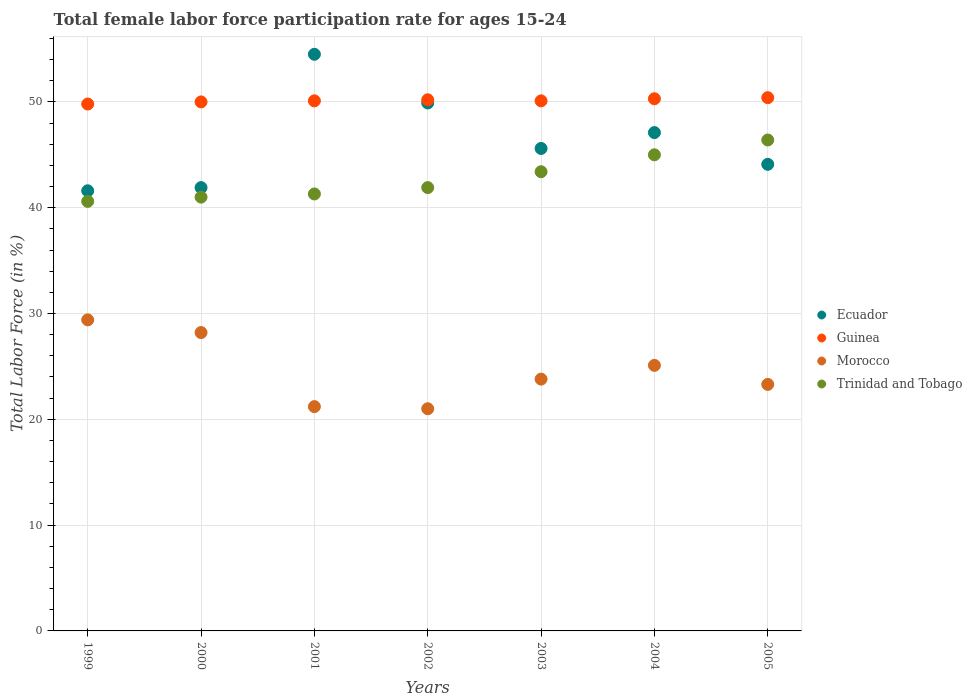Is the number of dotlines equal to the number of legend labels?
Offer a terse response. Yes. What is the female labor force participation rate in Ecuador in 2005?
Your response must be concise. 44.1. Across all years, what is the maximum female labor force participation rate in Guinea?
Offer a very short reply. 50.4. Across all years, what is the minimum female labor force participation rate in Ecuador?
Ensure brevity in your answer.  41.6. In which year was the female labor force participation rate in Guinea minimum?
Keep it short and to the point. 1999. What is the total female labor force participation rate in Morocco in the graph?
Offer a very short reply. 172. What is the difference between the female labor force participation rate in Guinea in 1999 and that in 2001?
Ensure brevity in your answer.  -0.3. What is the difference between the female labor force participation rate in Ecuador in 1999 and the female labor force participation rate in Guinea in 2005?
Provide a short and direct response. -8.8. What is the average female labor force participation rate in Guinea per year?
Ensure brevity in your answer.  50.13. In the year 2002, what is the difference between the female labor force participation rate in Morocco and female labor force participation rate in Ecuador?
Make the answer very short. -28.9. What is the ratio of the female labor force participation rate in Guinea in 2000 to that in 2003?
Offer a terse response. 1. Is the female labor force participation rate in Trinidad and Tobago in 2001 less than that in 2005?
Offer a very short reply. Yes. What is the difference between the highest and the second highest female labor force participation rate in Guinea?
Provide a succinct answer. 0.1. What is the difference between the highest and the lowest female labor force participation rate in Trinidad and Tobago?
Ensure brevity in your answer.  5.8. Does the female labor force participation rate in Trinidad and Tobago monotonically increase over the years?
Your answer should be very brief. Yes. Is the female labor force participation rate in Guinea strictly greater than the female labor force participation rate in Trinidad and Tobago over the years?
Your answer should be compact. Yes. How many dotlines are there?
Offer a very short reply. 4. Does the graph contain any zero values?
Give a very brief answer. No. How many legend labels are there?
Ensure brevity in your answer.  4. How are the legend labels stacked?
Provide a succinct answer. Vertical. What is the title of the graph?
Your answer should be compact. Total female labor force participation rate for ages 15-24. What is the label or title of the X-axis?
Provide a succinct answer. Years. What is the Total Labor Force (in %) of Ecuador in 1999?
Ensure brevity in your answer.  41.6. What is the Total Labor Force (in %) in Guinea in 1999?
Your answer should be very brief. 49.8. What is the Total Labor Force (in %) in Morocco in 1999?
Keep it short and to the point. 29.4. What is the Total Labor Force (in %) in Trinidad and Tobago in 1999?
Provide a succinct answer. 40.6. What is the Total Labor Force (in %) in Ecuador in 2000?
Provide a short and direct response. 41.9. What is the Total Labor Force (in %) in Morocco in 2000?
Your answer should be compact. 28.2. What is the Total Labor Force (in %) of Ecuador in 2001?
Ensure brevity in your answer.  54.5. What is the Total Labor Force (in %) in Guinea in 2001?
Give a very brief answer. 50.1. What is the Total Labor Force (in %) in Morocco in 2001?
Provide a succinct answer. 21.2. What is the Total Labor Force (in %) in Trinidad and Tobago in 2001?
Make the answer very short. 41.3. What is the Total Labor Force (in %) in Ecuador in 2002?
Make the answer very short. 49.9. What is the Total Labor Force (in %) of Guinea in 2002?
Your answer should be very brief. 50.2. What is the Total Labor Force (in %) of Trinidad and Tobago in 2002?
Your answer should be very brief. 41.9. What is the Total Labor Force (in %) of Ecuador in 2003?
Offer a terse response. 45.6. What is the Total Labor Force (in %) in Guinea in 2003?
Your response must be concise. 50.1. What is the Total Labor Force (in %) in Morocco in 2003?
Keep it short and to the point. 23.8. What is the Total Labor Force (in %) of Trinidad and Tobago in 2003?
Keep it short and to the point. 43.4. What is the Total Labor Force (in %) of Ecuador in 2004?
Ensure brevity in your answer.  47.1. What is the Total Labor Force (in %) in Guinea in 2004?
Provide a short and direct response. 50.3. What is the Total Labor Force (in %) in Morocco in 2004?
Offer a terse response. 25.1. What is the Total Labor Force (in %) of Trinidad and Tobago in 2004?
Your answer should be very brief. 45. What is the Total Labor Force (in %) in Ecuador in 2005?
Your response must be concise. 44.1. What is the Total Labor Force (in %) in Guinea in 2005?
Provide a short and direct response. 50.4. What is the Total Labor Force (in %) in Morocco in 2005?
Your answer should be compact. 23.3. What is the Total Labor Force (in %) in Trinidad and Tobago in 2005?
Give a very brief answer. 46.4. Across all years, what is the maximum Total Labor Force (in %) in Ecuador?
Provide a short and direct response. 54.5. Across all years, what is the maximum Total Labor Force (in %) in Guinea?
Provide a short and direct response. 50.4. Across all years, what is the maximum Total Labor Force (in %) of Morocco?
Ensure brevity in your answer.  29.4. Across all years, what is the maximum Total Labor Force (in %) in Trinidad and Tobago?
Make the answer very short. 46.4. Across all years, what is the minimum Total Labor Force (in %) in Ecuador?
Give a very brief answer. 41.6. Across all years, what is the minimum Total Labor Force (in %) of Guinea?
Provide a short and direct response. 49.8. Across all years, what is the minimum Total Labor Force (in %) of Morocco?
Offer a terse response. 21. Across all years, what is the minimum Total Labor Force (in %) of Trinidad and Tobago?
Make the answer very short. 40.6. What is the total Total Labor Force (in %) in Ecuador in the graph?
Ensure brevity in your answer.  324.7. What is the total Total Labor Force (in %) of Guinea in the graph?
Offer a terse response. 350.9. What is the total Total Labor Force (in %) in Morocco in the graph?
Provide a succinct answer. 172. What is the total Total Labor Force (in %) in Trinidad and Tobago in the graph?
Give a very brief answer. 299.6. What is the difference between the Total Labor Force (in %) of Ecuador in 1999 and that in 2000?
Give a very brief answer. -0.3. What is the difference between the Total Labor Force (in %) in Guinea in 1999 and that in 2000?
Offer a very short reply. -0.2. What is the difference between the Total Labor Force (in %) of Morocco in 1999 and that in 2000?
Give a very brief answer. 1.2. What is the difference between the Total Labor Force (in %) of Trinidad and Tobago in 1999 and that in 2000?
Make the answer very short. -0.4. What is the difference between the Total Labor Force (in %) in Guinea in 1999 and that in 2001?
Make the answer very short. -0.3. What is the difference between the Total Labor Force (in %) of Morocco in 1999 and that in 2001?
Offer a terse response. 8.2. What is the difference between the Total Labor Force (in %) of Trinidad and Tobago in 1999 and that in 2001?
Keep it short and to the point. -0.7. What is the difference between the Total Labor Force (in %) of Ecuador in 1999 and that in 2002?
Ensure brevity in your answer.  -8.3. What is the difference between the Total Labor Force (in %) of Guinea in 1999 and that in 2002?
Ensure brevity in your answer.  -0.4. What is the difference between the Total Labor Force (in %) of Morocco in 1999 and that in 2002?
Your answer should be compact. 8.4. What is the difference between the Total Labor Force (in %) in Ecuador in 1999 and that in 2003?
Offer a terse response. -4. What is the difference between the Total Labor Force (in %) in Guinea in 1999 and that in 2003?
Your answer should be compact. -0.3. What is the difference between the Total Labor Force (in %) of Morocco in 1999 and that in 2003?
Offer a terse response. 5.6. What is the difference between the Total Labor Force (in %) of Ecuador in 1999 and that in 2004?
Your answer should be compact. -5.5. What is the difference between the Total Labor Force (in %) in Morocco in 1999 and that in 2004?
Keep it short and to the point. 4.3. What is the difference between the Total Labor Force (in %) in Trinidad and Tobago in 1999 and that in 2004?
Offer a very short reply. -4.4. What is the difference between the Total Labor Force (in %) of Trinidad and Tobago in 1999 and that in 2005?
Make the answer very short. -5.8. What is the difference between the Total Labor Force (in %) in Guinea in 2000 and that in 2001?
Make the answer very short. -0.1. What is the difference between the Total Labor Force (in %) in Morocco in 2000 and that in 2001?
Keep it short and to the point. 7. What is the difference between the Total Labor Force (in %) in Trinidad and Tobago in 2000 and that in 2001?
Make the answer very short. -0.3. What is the difference between the Total Labor Force (in %) of Trinidad and Tobago in 2000 and that in 2002?
Provide a short and direct response. -0.9. What is the difference between the Total Labor Force (in %) in Ecuador in 2000 and that in 2003?
Offer a very short reply. -3.7. What is the difference between the Total Labor Force (in %) in Guinea in 2000 and that in 2003?
Provide a short and direct response. -0.1. What is the difference between the Total Labor Force (in %) in Ecuador in 2000 and that in 2004?
Offer a terse response. -5.2. What is the difference between the Total Labor Force (in %) in Guinea in 2000 and that in 2004?
Ensure brevity in your answer.  -0.3. What is the difference between the Total Labor Force (in %) of Morocco in 2000 and that in 2004?
Offer a terse response. 3.1. What is the difference between the Total Labor Force (in %) of Guinea in 2000 and that in 2005?
Your response must be concise. -0.4. What is the difference between the Total Labor Force (in %) of Morocco in 2000 and that in 2005?
Your answer should be very brief. 4.9. What is the difference between the Total Labor Force (in %) in Trinidad and Tobago in 2000 and that in 2005?
Your answer should be compact. -5.4. What is the difference between the Total Labor Force (in %) in Ecuador in 2001 and that in 2002?
Your response must be concise. 4.6. What is the difference between the Total Labor Force (in %) of Guinea in 2001 and that in 2002?
Your answer should be very brief. -0.1. What is the difference between the Total Labor Force (in %) of Trinidad and Tobago in 2001 and that in 2002?
Your answer should be very brief. -0.6. What is the difference between the Total Labor Force (in %) in Ecuador in 2001 and that in 2003?
Offer a very short reply. 8.9. What is the difference between the Total Labor Force (in %) in Guinea in 2001 and that in 2003?
Offer a very short reply. 0. What is the difference between the Total Labor Force (in %) in Morocco in 2001 and that in 2003?
Offer a terse response. -2.6. What is the difference between the Total Labor Force (in %) in Trinidad and Tobago in 2001 and that in 2003?
Make the answer very short. -2.1. What is the difference between the Total Labor Force (in %) in Guinea in 2001 and that in 2004?
Offer a terse response. -0.2. What is the difference between the Total Labor Force (in %) in Guinea in 2001 and that in 2005?
Offer a very short reply. -0.3. What is the difference between the Total Labor Force (in %) of Trinidad and Tobago in 2002 and that in 2003?
Provide a short and direct response. -1.5. What is the difference between the Total Labor Force (in %) of Morocco in 2002 and that in 2004?
Ensure brevity in your answer.  -4.1. What is the difference between the Total Labor Force (in %) in Guinea in 2002 and that in 2005?
Offer a terse response. -0.2. What is the difference between the Total Labor Force (in %) in Morocco in 2002 and that in 2005?
Your answer should be compact. -2.3. What is the difference between the Total Labor Force (in %) of Trinidad and Tobago in 2002 and that in 2005?
Your answer should be compact. -4.5. What is the difference between the Total Labor Force (in %) in Ecuador in 2003 and that in 2004?
Provide a short and direct response. -1.5. What is the difference between the Total Labor Force (in %) in Ecuador in 2003 and that in 2005?
Ensure brevity in your answer.  1.5. What is the difference between the Total Labor Force (in %) in Trinidad and Tobago in 2003 and that in 2005?
Provide a succinct answer. -3. What is the difference between the Total Labor Force (in %) of Ecuador in 2004 and that in 2005?
Provide a succinct answer. 3. What is the difference between the Total Labor Force (in %) in Morocco in 2004 and that in 2005?
Give a very brief answer. 1.8. What is the difference between the Total Labor Force (in %) of Trinidad and Tobago in 2004 and that in 2005?
Provide a succinct answer. -1.4. What is the difference between the Total Labor Force (in %) in Ecuador in 1999 and the Total Labor Force (in %) in Morocco in 2000?
Offer a very short reply. 13.4. What is the difference between the Total Labor Force (in %) of Guinea in 1999 and the Total Labor Force (in %) of Morocco in 2000?
Your answer should be compact. 21.6. What is the difference between the Total Labor Force (in %) in Guinea in 1999 and the Total Labor Force (in %) in Trinidad and Tobago in 2000?
Your answer should be compact. 8.8. What is the difference between the Total Labor Force (in %) of Morocco in 1999 and the Total Labor Force (in %) of Trinidad and Tobago in 2000?
Keep it short and to the point. -11.6. What is the difference between the Total Labor Force (in %) in Ecuador in 1999 and the Total Labor Force (in %) in Guinea in 2001?
Ensure brevity in your answer.  -8.5. What is the difference between the Total Labor Force (in %) in Ecuador in 1999 and the Total Labor Force (in %) in Morocco in 2001?
Provide a succinct answer. 20.4. What is the difference between the Total Labor Force (in %) of Ecuador in 1999 and the Total Labor Force (in %) of Trinidad and Tobago in 2001?
Offer a terse response. 0.3. What is the difference between the Total Labor Force (in %) in Guinea in 1999 and the Total Labor Force (in %) in Morocco in 2001?
Give a very brief answer. 28.6. What is the difference between the Total Labor Force (in %) of Guinea in 1999 and the Total Labor Force (in %) of Trinidad and Tobago in 2001?
Give a very brief answer. 8.5. What is the difference between the Total Labor Force (in %) of Ecuador in 1999 and the Total Labor Force (in %) of Guinea in 2002?
Your response must be concise. -8.6. What is the difference between the Total Labor Force (in %) in Ecuador in 1999 and the Total Labor Force (in %) in Morocco in 2002?
Ensure brevity in your answer.  20.6. What is the difference between the Total Labor Force (in %) in Guinea in 1999 and the Total Labor Force (in %) in Morocco in 2002?
Offer a terse response. 28.8. What is the difference between the Total Labor Force (in %) in Morocco in 1999 and the Total Labor Force (in %) in Trinidad and Tobago in 2002?
Your answer should be compact. -12.5. What is the difference between the Total Labor Force (in %) of Ecuador in 1999 and the Total Labor Force (in %) of Guinea in 2003?
Offer a terse response. -8.5. What is the difference between the Total Labor Force (in %) of Ecuador in 1999 and the Total Labor Force (in %) of Morocco in 2003?
Your answer should be very brief. 17.8. What is the difference between the Total Labor Force (in %) of Guinea in 1999 and the Total Labor Force (in %) of Trinidad and Tobago in 2003?
Your answer should be compact. 6.4. What is the difference between the Total Labor Force (in %) in Guinea in 1999 and the Total Labor Force (in %) in Morocco in 2004?
Your response must be concise. 24.7. What is the difference between the Total Labor Force (in %) in Guinea in 1999 and the Total Labor Force (in %) in Trinidad and Tobago in 2004?
Provide a short and direct response. 4.8. What is the difference between the Total Labor Force (in %) in Morocco in 1999 and the Total Labor Force (in %) in Trinidad and Tobago in 2004?
Keep it short and to the point. -15.6. What is the difference between the Total Labor Force (in %) in Ecuador in 1999 and the Total Labor Force (in %) in Guinea in 2005?
Offer a very short reply. -8.8. What is the difference between the Total Labor Force (in %) in Guinea in 1999 and the Total Labor Force (in %) in Morocco in 2005?
Provide a succinct answer. 26.5. What is the difference between the Total Labor Force (in %) in Guinea in 1999 and the Total Labor Force (in %) in Trinidad and Tobago in 2005?
Your response must be concise. 3.4. What is the difference between the Total Labor Force (in %) of Ecuador in 2000 and the Total Labor Force (in %) of Guinea in 2001?
Ensure brevity in your answer.  -8.2. What is the difference between the Total Labor Force (in %) in Ecuador in 2000 and the Total Labor Force (in %) in Morocco in 2001?
Ensure brevity in your answer.  20.7. What is the difference between the Total Labor Force (in %) in Ecuador in 2000 and the Total Labor Force (in %) in Trinidad and Tobago in 2001?
Keep it short and to the point. 0.6. What is the difference between the Total Labor Force (in %) in Guinea in 2000 and the Total Labor Force (in %) in Morocco in 2001?
Ensure brevity in your answer.  28.8. What is the difference between the Total Labor Force (in %) of Ecuador in 2000 and the Total Labor Force (in %) of Morocco in 2002?
Ensure brevity in your answer.  20.9. What is the difference between the Total Labor Force (in %) in Morocco in 2000 and the Total Labor Force (in %) in Trinidad and Tobago in 2002?
Give a very brief answer. -13.7. What is the difference between the Total Labor Force (in %) in Ecuador in 2000 and the Total Labor Force (in %) in Guinea in 2003?
Ensure brevity in your answer.  -8.2. What is the difference between the Total Labor Force (in %) of Ecuador in 2000 and the Total Labor Force (in %) of Morocco in 2003?
Your response must be concise. 18.1. What is the difference between the Total Labor Force (in %) of Ecuador in 2000 and the Total Labor Force (in %) of Trinidad and Tobago in 2003?
Offer a terse response. -1.5. What is the difference between the Total Labor Force (in %) in Guinea in 2000 and the Total Labor Force (in %) in Morocco in 2003?
Offer a very short reply. 26.2. What is the difference between the Total Labor Force (in %) of Morocco in 2000 and the Total Labor Force (in %) of Trinidad and Tobago in 2003?
Make the answer very short. -15.2. What is the difference between the Total Labor Force (in %) in Ecuador in 2000 and the Total Labor Force (in %) in Morocco in 2004?
Make the answer very short. 16.8. What is the difference between the Total Labor Force (in %) of Guinea in 2000 and the Total Labor Force (in %) of Morocco in 2004?
Offer a very short reply. 24.9. What is the difference between the Total Labor Force (in %) of Guinea in 2000 and the Total Labor Force (in %) of Trinidad and Tobago in 2004?
Offer a very short reply. 5. What is the difference between the Total Labor Force (in %) in Morocco in 2000 and the Total Labor Force (in %) in Trinidad and Tobago in 2004?
Ensure brevity in your answer.  -16.8. What is the difference between the Total Labor Force (in %) in Ecuador in 2000 and the Total Labor Force (in %) in Guinea in 2005?
Offer a very short reply. -8.5. What is the difference between the Total Labor Force (in %) in Ecuador in 2000 and the Total Labor Force (in %) in Morocco in 2005?
Keep it short and to the point. 18.6. What is the difference between the Total Labor Force (in %) in Guinea in 2000 and the Total Labor Force (in %) in Morocco in 2005?
Offer a terse response. 26.7. What is the difference between the Total Labor Force (in %) in Guinea in 2000 and the Total Labor Force (in %) in Trinidad and Tobago in 2005?
Offer a terse response. 3.6. What is the difference between the Total Labor Force (in %) in Morocco in 2000 and the Total Labor Force (in %) in Trinidad and Tobago in 2005?
Your response must be concise. -18.2. What is the difference between the Total Labor Force (in %) in Ecuador in 2001 and the Total Labor Force (in %) in Morocco in 2002?
Your answer should be compact. 33.5. What is the difference between the Total Labor Force (in %) in Guinea in 2001 and the Total Labor Force (in %) in Morocco in 2002?
Your answer should be compact. 29.1. What is the difference between the Total Labor Force (in %) of Morocco in 2001 and the Total Labor Force (in %) of Trinidad and Tobago in 2002?
Give a very brief answer. -20.7. What is the difference between the Total Labor Force (in %) in Ecuador in 2001 and the Total Labor Force (in %) in Morocco in 2003?
Make the answer very short. 30.7. What is the difference between the Total Labor Force (in %) in Guinea in 2001 and the Total Labor Force (in %) in Morocco in 2003?
Ensure brevity in your answer.  26.3. What is the difference between the Total Labor Force (in %) of Guinea in 2001 and the Total Labor Force (in %) of Trinidad and Tobago in 2003?
Offer a terse response. 6.7. What is the difference between the Total Labor Force (in %) of Morocco in 2001 and the Total Labor Force (in %) of Trinidad and Tobago in 2003?
Your answer should be compact. -22.2. What is the difference between the Total Labor Force (in %) in Ecuador in 2001 and the Total Labor Force (in %) in Guinea in 2004?
Your response must be concise. 4.2. What is the difference between the Total Labor Force (in %) of Ecuador in 2001 and the Total Labor Force (in %) of Morocco in 2004?
Keep it short and to the point. 29.4. What is the difference between the Total Labor Force (in %) in Ecuador in 2001 and the Total Labor Force (in %) in Trinidad and Tobago in 2004?
Keep it short and to the point. 9.5. What is the difference between the Total Labor Force (in %) in Guinea in 2001 and the Total Labor Force (in %) in Morocco in 2004?
Give a very brief answer. 25. What is the difference between the Total Labor Force (in %) in Morocco in 2001 and the Total Labor Force (in %) in Trinidad and Tobago in 2004?
Your response must be concise. -23.8. What is the difference between the Total Labor Force (in %) in Ecuador in 2001 and the Total Labor Force (in %) in Morocco in 2005?
Give a very brief answer. 31.2. What is the difference between the Total Labor Force (in %) in Guinea in 2001 and the Total Labor Force (in %) in Morocco in 2005?
Give a very brief answer. 26.8. What is the difference between the Total Labor Force (in %) in Guinea in 2001 and the Total Labor Force (in %) in Trinidad and Tobago in 2005?
Your answer should be compact. 3.7. What is the difference between the Total Labor Force (in %) in Morocco in 2001 and the Total Labor Force (in %) in Trinidad and Tobago in 2005?
Your answer should be compact. -25.2. What is the difference between the Total Labor Force (in %) in Ecuador in 2002 and the Total Labor Force (in %) in Morocco in 2003?
Offer a terse response. 26.1. What is the difference between the Total Labor Force (in %) in Ecuador in 2002 and the Total Labor Force (in %) in Trinidad and Tobago in 2003?
Give a very brief answer. 6.5. What is the difference between the Total Labor Force (in %) in Guinea in 2002 and the Total Labor Force (in %) in Morocco in 2003?
Your answer should be very brief. 26.4. What is the difference between the Total Labor Force (in %) in Guinea in 2002 and the Total Labor Force (in %) in Trinidad and Tobago in 2003?
Your answer should be very brief. 6.8. What is the difference between the Total Labor Force (in %) of Morocco in 2002 and the Total Labor Force (in %) of Trinidad and Tobago in 2003?
Provide a succinct answer. -22.4. What is the difference between the Total Labor Force (in %) of Ecuador in 2002 and the Total Labor Force (in %) of Morocco in 2004?
Make the answer very short. 24.8. What is the difference between the Total Labor Force (in %) of Guinea in 2002 and the Total Labor Force (in %) of Morocco in 2004?
Provide a short and direct response. 25.1. What is the difference between the Total Labor Force (in %) in Guinea in 2002 and the Total Labor Force (in %) in Trinidad and Tobago in 2004?
Make the answer very short. 5.2. What is the difference between the Total Labor Force (in %) in Morocco in 2002 and the Total Labor Force (in %) in Trinidad and Tobago in 2004?
Your response must be concise. -24. What is the difference between the Total Labor Force (in %) of Ecuador in 2002 and the Total Labor Force (in %) of Morocco in 2005?
Your answer should be very brief. 26.6. What is the difference between the Total Labor Force (in %) of Guinea in 2002 and the Total Labor Force (in %) of Morocco in 2005?
Make the answer very short. 26.9. What is the difference between the Total Labor Force (in %) of Morocco in 2002 and the Total Labor Force (in %) of Trinidad and Tobago in 2005?
Your answer should be compact. -25.4. What is the difference between the Total Labor Force (in %) in Ecuador in 2003 and the Total Labor Force (in %) in Trinidad and Tobago in 2004?
Offer a very short reply. 0.6. What is the difference between the Total Labor Force (in %) in Guinea in 2003 and the Total Labor Force (in %) in Morocco in 2004?
Your response must be concise. 25. What is the difference between the Total Labor Force (in %) in Guinea in 2003 and the Total Labor Force (in %) in Trinidad and Tobago in 2004?
Your answer should be very brief. 5.1. What is the difference between the Total Labor Force (in %) in Morocco in 2003 and the Total Labor Force (in %) in Trinidad and Tobago in 2004?
Your answer should be very brief. -21.2. What is the difference between the Total Labor Force (in %) in Ecuador in 2003 and the Total Labor Force (in %) in Guinea in 2005?
Your answer should be compact. -4.8. What is the difference between the Total Labor Force (in %) in Ecuador in 2003 and the Total Labor Force (in %) in Morocco in 2005?
Your answer should be compact. 22.3. What is the difference between the Total Labor Force (in %) in Ecuador in 2003 and the Total Labor Force (in %) in Trinidad and Tobago in 2005?
Give a very brief answer. -0.8. What is the difference between the Total Labor Force (in %) of Guinea in 2003 and the Total Labor Force (in %) of Morocco in 2005?
Provide a succinct answer. 26.8. What is the difference between the Total Labor Force (in %) of Guinea in 2003 and the Total Labor Force (in %) of Trinidad and Tobago in 2005?
Make the answer very short. 3.7. What is the difference between the Total Labor Force (in %) in Morocco in 2003 and the Total Labor Force (in %) in Trinidad and Tobago in 2005?
Your answer should be compact. -22.6. What is the difference between the Total Labor Force (in %) in Ecuador in 2004 and the Total Labor Force (in %) in Guinea in 2005?
Make the answer very short. -3.3. What is the difference between the Total Labor Force (in %) in Ecuador in 2004 and the Total Labor Force (in %) in Morocco in 2005?
Give a very brief answer. 23.8. What is the difference between the Total Labor Force (in %) in Ecuador in 2004 and the Total Labor Force (in %) in Trinidad and Tobago in 2005?
Provide a short and direct response. 0.7. What is the difference between the Total Labor Force (in %) in Guinea in 2004 and the Total Labor Force (in %) in Morocco in 2005?
Offer a very short reply. 27. What is the difference between the Total Labor Force (in %) of Guinea in 2004 and the Total Labor Force (in %) of Trinidad and Tobago in 2005?
Your response must be concise. 3.9. What is the difference between the Total Labor Force (in %) in Morocco in 2004 and the Total Labor Force (in %) in Trinidad and Tobago in 2005?
Give a very brief answer. -21.3. What is the average Total Labor Force (in %) of Ecuador per year?
Your answer should be very brief. 46.39. What is the average Total Labor Force (in %) in Guinea per year?
Your response must be concise. 50.13. What is the average Total Labor Force (in %) in Morocco per year?
Your answer should be very brief. 24.57. What is the average Total Labor Force (in %) of Trinidad and Tobago per year?
Provide a short and direct response. 42.8. In the year 1999, what is the difference between the Total Labor Force (in %) of Ecuador and Total Labor Force (in %) of Morocco?
Offer a very short reply. 12.2. In the year 1999, what is the difference between the Total Labor Force (in %) in Ecuador and Total Labor Force (in %) in Trinidad and Tobago?
Your response must be concise. 1. In the year 1999, what is the difference between the Total Labor Force (in %) in Guinea and Total Labor Force (in %) in Morocco?
Your answer should be compact. 20.4. In the year 1999, what is the difference between the Total Labor Force (in %) of Morocco and Total Labor Force (in %) of Trinidad and Tobago?
Your response must be concise. -11.2. In the year 2000, what is the difference between the Total Labor Force (in %) in Ecuador and Total Labor Force (in %) in Morocco?
Give a very brief answer. 13.7. In the year 2000, what is the difference between the Total Labor Force (in %) in Ecuador and Total Labor Force (in %) in Trinidad and Tobago?
Provide a short and direct response. 0.9. In the year 2000, what is the difference between the Total Labor Force (in %) of Guinea and Total Labor Force (in %) of Morocco?
Provide a succinct answer. 21.8. In the year 2000, what is the difference between the Total Labor Force (in %) of Morocco and Total Labor Force (in %) of Trinidad and Tobago?
Give a very brief answer. -12.8. In the year 2001, what is the difference between the Total Labor Force (in %) in Ecuador and Total Labor Force (in %) in Morocco?
Keep it short and to the point. 33.3. In the year 2001, what is the difference between the Total Labor Force (in %) of Guinea and Total Labor Force (in %) of Morocco?
Provide a short and direct response. 28.9. In the year 2001, what is the difference between the Total Labor Force (in %) of Morocco and Total Labor Force (in %) of Trinidad and Tobago?
Offer a very short reply. -20.1. In the year 2002, what is the difference between the Total Labor Force (in %) of Ecuador and Total Labor Force (in %) of Morocco?
Offer a terse response. 28.9. In the year 2002, what is the difference between the Total Labor Force (in %) of Guinea and Total Labor Force (in %) of Morocco?
Provide a succinct answer. 29.2. In the year 2002, what is the difference between the Total Labor Force (in %) in Guinea and Total Labor Force (in %) in Trinidad and Tobago?
Make the answer very short. 8.3. In the year 2002, what is the difference between the Total Labor Force (in %) in Morocco and Total Labor Force (in %) in Trinidad and Tobago?
Ensure brevity in your answer.  -20.9. In the year 2003, what is the difference between the Total Labor Force (in %) of Ecuador and Total Labor Force (in %) of Guinea?
Provide a succinct answer. -4.5. In the year 2003, what is the difference between the Total Labor Force (in %) of Ecuador and Total Labor Force (in %) of Morocco?
Your answer should be very brief. 21.8. In the year 2003, what is the difference between the Total Labor Force (in %) in Guinea and Total Labor Force (in %) in Morocco?
Ensure brevity in your answer.  26.3. In the year 2003, what is the difference between the Total Labor Force (in %) in Guinea and Total Labor Force (in %) in Trinidad and Tobago?
Provide a short and direct response. 6.7. In the year 2003, what is the difference between the Total Labor Force (in %) in Morocco and Total Labor Force (in %) in Trinidad and Tobago?
Your response must be concise. -19.6. In the year 2004, what is the difference between the Total Labor Force (in %) in Guinea and Total Labor Force (in %) in Morocco?
Give a very brief answer. 25.2. In the year 2004, what is the difference between the Total Labor Force (in %) in Morocco and Total Labor Force (in %) in Trinidad and Tobago?
Your answer should be compact. -19.9. In the year 2005, what is the difference between the Total Labor Force (in %) of Ecuador and Total Labor Force (in %) of Guinea?
Offer a terse response. -6.3. In the year 2005, what is the difference between the Total Labor Force (in %) of Ecuador and Total Labor Force (in %) of Morocco?
Make the answer very short. 20.8. In the year 2005, what is the difference between the Total Labor Force (in %) of Ecuador and Total Labor Force (in %) of Trinidad and Tobago?
Keep it short and to the point. -2.3. In the year 2005, what is the difference between the Total Labor Force (in %) of Guinea and Total Labor Force (in %) of Morocco?
Your answer should be compact. 27.1. In the year 2005, what is the difference between the Total Labor Force (in %) in Guinea and Total Labor Force (in %) in Trinidad and Tobago?
Provide a succinct answer. 4. In the year 2005, what is the difference between the Total Labor Force (in %) in Morocco and Total Labor Force (in %) in Trinidad and Tobago?
Ensure brevity in your answer.  -23.1. What is the ratio of the Total Labor Force (in %) of Ecuador in 1999 to that in 2000?
Keep it short and to the point. 0.99. What is the ratio of the Total Labor Force (in %) of Morocco in 1999 to that in 2000?
Give a very brief answer. 1.04. What is the ratio of the Total Labor Force (in %) of Trinidad and Tobago in 1999 to that in 2000?
Your answer should be compact. 0.99. What is the ratio of the Total Labor Force (in %) of Ecuador in 1999 to that in 2001?
Your answer should be very brief. 0.76. What is the ratio of the Total Labor Force (in %) of Guinea in 1999 to that in 2001?
Your answer should be compact. 0.99. What is the ratio of the Total Labor Force (in %) of Morocco in 1999 to that in 2001?
Offer a terse response. 1.39. What is the ratio of the Total Labor Force (in %) of Trinidad and Tobago in 1999 to that in 2001?
Your answer should be compact. 0.98. What is the ratio of the Total Labor Force (in %) of Ecuador in 1999 to that in 2002?
Ensure brevity in your answer.  0.83. What is the ratio of the Total Labor Force (in %) of Ecuador in 1999 to that in 2003?
Offer a terse response. 0.91. What is the ratio of the Total Labor Force (in %) of Guinea in 1999 to that in 2003?
Your response must be concise. 0.99. What is the ratio of the Total Labor Force (in %) in Morocco in 1999 to that in 2003?
Give a very brief answer. 1.24. What is the ratio of the Total Labor Force (in %) of Trinidad and Tobago in 1999 to that in 2003?
Offer a terse response. 0.94. What is the ratio of the Total Labor Force (in %) in Ecuador in 1999 to that in 2004?
Offer a terse response. 0.88. What is the ratio of the Total Labor Force (in %) in Morocco in 1999 to that in 2004?
Your response must be concise. 1.17. What is the ratio of the Total Labor Force (in %) in Trinidad and Tobago in 1999 to that in 2004?
Provide a short and direct response. 0.9. What is the ratio of the Total Labor Force (in %) of Ecuador in 1999 to that in 2005?
Your answer should be compact. 0.94. What is the ratio of the Total Labor Force (in %) in Guinea in 1999 to that in 2005?
Make the answer very short. 0.99. What is the ratio of the Total Labor Force (in %) in Morocco in 1999 to that in 2005?
Offer a terse response. 1.26. What is the ratio of the Total Labor Force (in %) in Ecuador in 2000 to that in 2001?
Provide a short and direct response. 0.77. What is the ratio of the Total Labor Force (in %) of Morocco in 2000 to that in 2001?
Give a very brief answer. 1.33. What is the ratio of the Total Labor Force (in %) of Ecuador in 2000 to that in 2002?
Provide a succinct answer. 0.84. What is the ratio of the Total Labor Force (in %) of Morocco in 2000 to that in 2002?
Ensure brevity in your answer.  1.34. What is the ratio of the Total Labor Force (in %) in Trinidad and Tobago in 2000 to that in 2002?
Your answer should be very brief. 0.98. What is the ratio of the Total Labor Force (in %) of Ecuador in 2000 to that in 2003?
Your answer should be compact. 0.92. What is the ratio of the Total Labor Force (in %) of Morocco in 2000 to that in 2003?
Your response must be concise. 1.18. What is the ratio of the Total Labor Force (in %) in Trinidad and Tobago in 2000 to that in 2003?
Ensure brevity in your answer.  0.94. What is the ratio of the Total Labor Force (in %) in Ecuador in 2000 to that in 2004?
Keep it short and to the point. 0.89. What is the ratio of the Total Labor Force (in %) of Guinea in 2000 to that in 2004?
Offer a terse response. 0.99. What is the ratio of the Total Labor Force (in %) in Morocco in 2000 to that in 2004?
Provide a short and direct response. 1.12. What is the ratio of the Total Labor Force (in %) in Trinidad and Tobago in 2000 to that in 2004?
Make the answer very short. 0.91. What is the ratio of the Total Labor Force (in %) in Ecuador in 2000 to that in 2005?
Make the answer very short. 0.95. What is the ratio of the Total Labor Force (in %) in Guinea in 2000 to that in 2005?
Ensure brevity in your answer.  0.99. What is the ratio of the Total Labor Force (in %) in Morocco in 2000 to that in 2005?
Offer a terse response. 1.21. What is the ratio of the Total Labor Force (in %) in Trinidad and Tobago in 2000 to that in 2005?
Give a very brief answer. 0.88. What is the ratio of the Total Labor Force (in %) in Ecuador in 2001 to that in 2002?
Offer a terse response. 1.09. What is the ratio of the Total Labor Force (in %) of Guinea in 2001 to that in 2002?
Offer a terse response. 1. What is the ratio of the Total Labor Force (in %) of Morocco in 2001 to that in 2002?
Give a very brief answer. 1.01. What is the ratio of the Total Labor Force (in %) of Trinidad and Tobago in 2001 to that in 2002?
Your response must be concise. 0.99. What is the ratio of the Total Labor Force (in %) in Ecuador in 2001 to that in 2003?
Provide a succinct answer. 1.2. What is the ratio of the Total Labor Force (in %) of Morocco in 2001 to that in 2003?
Ensure brevity in your answer.  0.89. What is the ratio of the Total Labor Force (in %) of Trinidad and Tobago in 2001 to that in 2003?
Keep it short and to the point. 0.95. What is the ratio of the Total Labor Force (in %) in Ecuador in 2001 to that in 2004?
Your answer should be very brief. 1.16. What is the ratio of the Total Labor Force (in %) in Morocco in 2001 to that in 2004?
Provide a short and direct response. 0.84. What is the ratio of the Total Labor Force (in %) of Trinidad and Tobago in 2001 to that in 2004?
Offer a very short reply. 0.92. What is the ratio of the Total Labor Force (in %) of Ecuador in 2001 to that in 2005?
Ensure brevity in your answer.  1.24. What is the ratio of the Total Labor Force (in %) in Morocco in 2001 to that in 2005?
Your answer should be compact. 0.91. What is the ratio of the Total Labor Force (in %) in Trinidad and Tobago in 2001 to that in 2005?
Provide a short and direct response. 0.89. What is the ratio of the Total Labor Force (in %) in Ecuador in 2002 to that in 2003?
Give a very brief answer. 1.09. What is the ratio of the Total Labor Force (in %) in Morocco in 2002 to that in 2003?
Your answer should be very brief. 0.88. What is the ratio of the Total Labor Force (in %) in Trinidad and Tobago in 2002 to that in 2003?
Provide a short and direct response. 0.97. What is the ratio of the Total Labor Force (in %) of Ecuador in 2002 to that in 2004?
Offer a terse response. 1.06. What is the ratio of the Total Labor Force (in %) in Morocco in 2002 to that in 2004?
Your answer should be compact. 0.84. What is the ratio of the Total Labor Force (in %) of Trinidad and Tobago in 2002 to that in 2004?
Your answer should be compact. 0.93. What is the ratio of the Total Labor Force (in %) of Ecuador in 2002 to that in 2005?
Offer a very short reply. 1.13. What is the ratio of the Total Labor Force (in %) in Morocco in 2002 to that in 2005?
Your answer should be very brief. 0.9. What is the ratio of the Total Labor Force (in %) in Trinidad and Tobago in 2002 to that in 2005?
Your response must be concise. 0.9. What is the ratio of the Total Labor Force (in %) in Ecuador in 2003 to that in 2004?
Keep it short and to the point. 0.97. What is the ratio of the Total Labor Force (in %) in Morocco in 2003 to that in 2004?
Provide a succinct answer. 0.95. What is the ratio of the Total Labor Force (in %) of Trinidad and Tobago in 2003 to that in 2004?
Your answer should be very brief. 0.96. What is the ratio of the Total Labor Force (in %) of Ecuador in 2003 to that in 2005?
Give a very brief answer. 1.03. What is the ratio of the Total Labor Force (in %) of Guinea in 2003 to that in 2005?
Keep it short and to the point. 0.99. What is the ratio of the Total Labor Force (in %) in Morocco in 2003 to that in 2005?
Keep it short and to the point. 1.02. What is the ratio of the Total Labor Force (in %) of Trinidad and Tobago in 2003 to that in 2005?
Your response must be concise. 0.94. What is the ratio of the Total Labor Force (in %) in Ecuador in 2004 to that in 2005?
Your answer should be compact. 1.07. What is the ratio of the Total Labor Force (in %) in Morocco in 2004 to that in 2005?
Your answer should be very brief. 1.08. What is the ratio of the Total Labor Force (in %) in Trinidad and Tobago in 2004 to that in 2005?
Make the answer very short. 0.97. What is the difference between the highest and the second highest Total Labor Force (in %) in Ecuador?
Your response must be concise. 4.6. What is the difference between the highest and the lowest Total Labor Force (in %) in Morocco?
Keep it short and to the point. 8.4. 